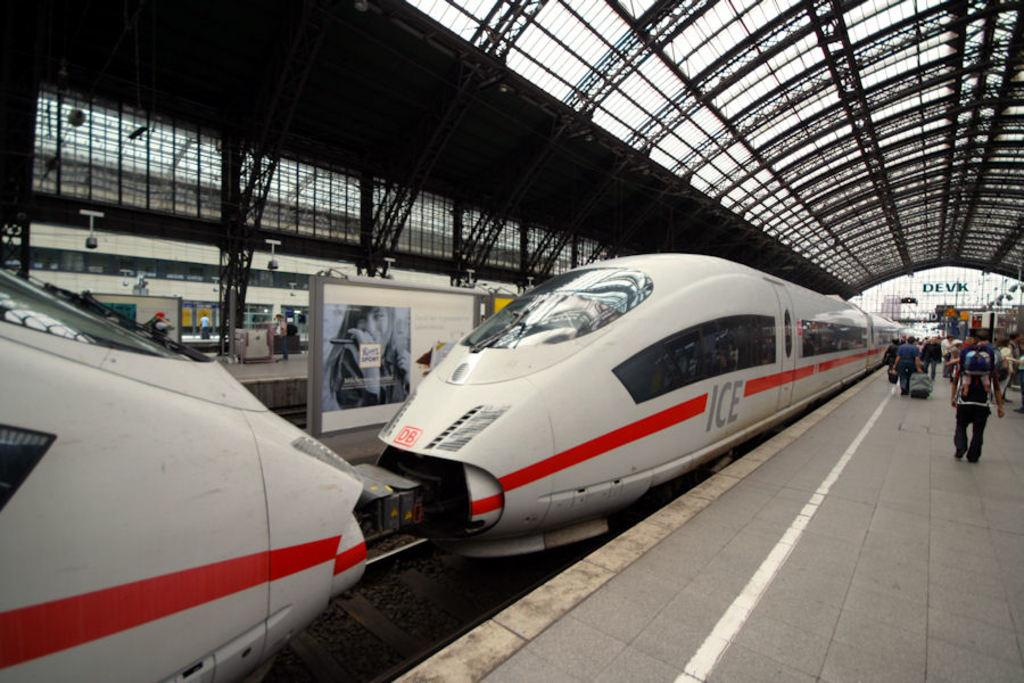Provide a one-sentence caption for the provided image. an electric train with the word ICE on it is waiting to be boarded. 